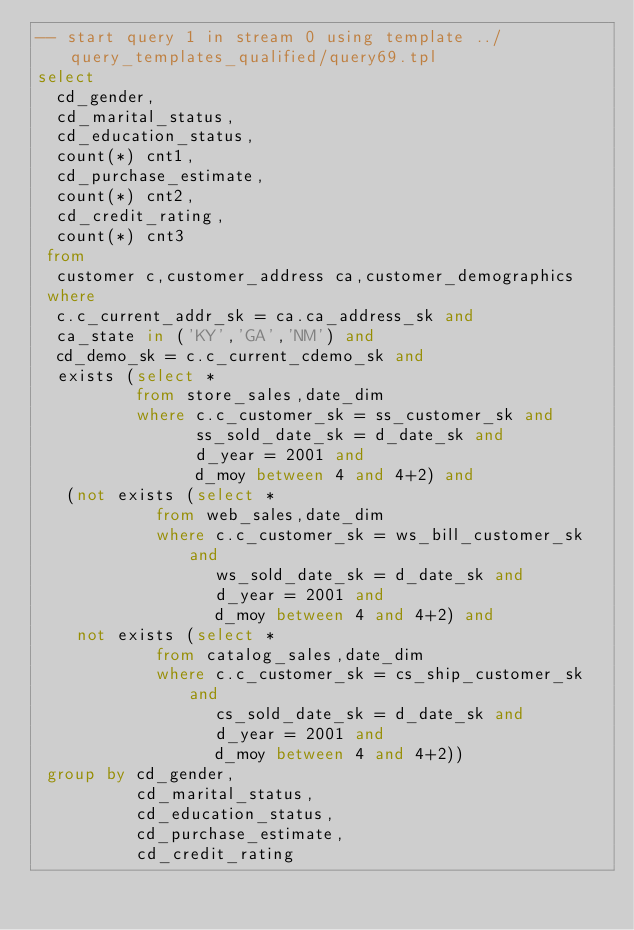<code> <loc_0><loc_0><loc_500><loc_500><_SQL_>-- start query 1 in stream 0 using template ../query_templates_qualified/query69.tpl
select  
  cd_gender,
  cd_marital_status,
  cd_education_status,
  count(*) cnt1,
  cd_purchase_estimate,
  count(*) cnt2,
  cd_credit_rating,
  count(*) cnt3
 from
  customer c,customer_address ca,customer_demographics
 where
  c.c_current_addr_sk = ca.ca_address_sk and
  ca_state in ('KY','GA','NM') and
  cd_demo_sk = c.c_current_cdemo_sk and 
  exists (select *
          from store_sales,date_dim
          where c.c_customer_sk = ss_customer_sk and
                ss_sold_date_sk = d_date_sk and
                d_year = 2001 and
                d_moy between 4 and 4+2) and
   (not exists (select *
            from web_sales,date_dim
            where c.c_customer_sk = ws_bill_customer_sk and
                  ws_sold_date_sk = d_date_sk and
                  d_year = 2001 and
                  d_moy between 4 and 4+2) and
    not exists (select * 
            from catalog_sales,date_dim
            where c.c_customer_sk = cs_ship_customer_sk and
                  cs_sold_date_sk = d_date_sk and
                  d_year = 2001 and
                  d_moy between 4 and 4+2))
 group by cd_gender,
          cd_marital_status,
          cd_education_status,
          cd_purchase_estimate,
          cd_credit_rating</code> 